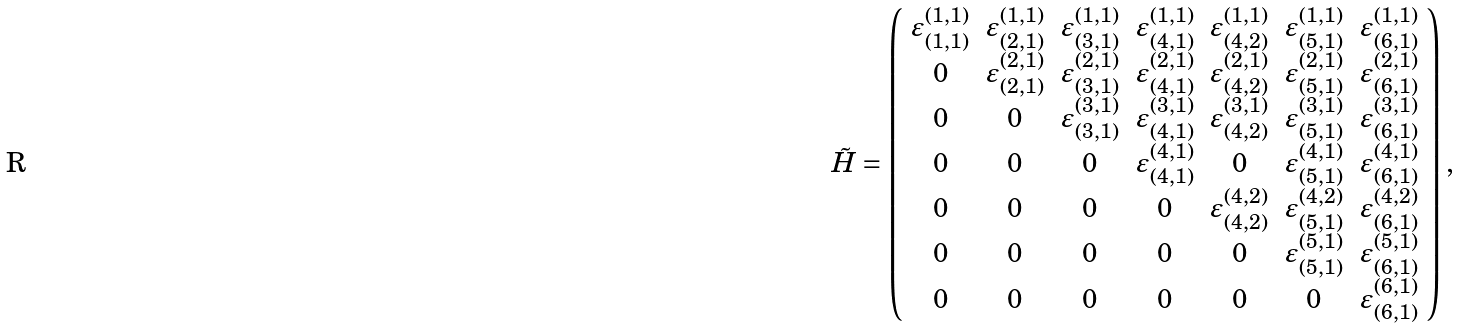Convert formula to latex. <formula><loc_0><loc_0><loc_500><loc_500>\tilde { H } = \left ( \begin{array} { c c c c c c c } \varepsilon ^ { ( 1 , 1 ) } _ { ( 1 , 1 ) } & \varepsilon ^ { ( 1 , 1 ) } _ { ( 2 , 1 ) } & \varepsilon ^ { ( 1 , 1 ) } _ { ( 3 , 1 ) } & \varepsilon ^ { ( 1 , 1 ) } _ { ( 4 , 1 ) } & \varepsilon ^ { ( 1 , 1 ) } _ { ( 4 , 2 ) } & \varepsilon ^ { ( 1 , 1 ) } _ { ( 5 , 1 ) } & \varepsilon ^ { ( 1 , 1 ) } _ { ( 6 , 1 ) } \\ 0 & \varepsilon ^ { ( 2 , 1 ) } _ { ( 2 , 1 ) } & \varepsilon ^ { ( 2 , 1 ) } _ { ( 3 , 1 ) } & \varepsilon ^ { ( 2 , 1 ) } _ { ( 4 , 1 ) } & \varepsilon ^ { ( 2 , 1 ) } _ { ( 4 , 2 ) } & \varepsilon ^ { ( 2 , 1 ) } _ { ( 5 , 1 ) } & \varepsilon ^ { ( 2 , 1 ) } _ { ( 6 , 1 ) } \\ 0 & 0 & \varepsilon ^ { ( 3 , 1 ) } _ { ( 3 , 1 ) } & \varepsilon ^ { ( 3 , 1 ) } _ { ( 4 , 1 ) } & \varepsilon ^ { ( 3 , 1 ) } _ { ( 4 , 2 ) } & \varepsilon ^ { ( 3 , 1 ) } _ { ( 5 , 1 ) } & \varepsilon ^ { ( 3 , 1 ) } _ { ( 6 , 1 ) } \\ 0 & 0 & 0 & \varepsilon ^ { ( 4 , 1 ) } _ { ( 4 , 1 ) } & 0 & \varepsilon ^ { ( 4 , 1 ) } _ { ( 5 , 1 ) } & \varepsilon ^ { ( 4 , 1 ) } _ { ( 6 , 1 ) } \\ 0 & 0 & 0 & 0 & \varepsilon ^ { ( 4 , 2 ) } _ { ( 4 , 2 ) } & \varepsilon ^ { ( 4 , 2 ) } _ { ( 5 , 1 ) } & \varepsilon ^ { ( 4 , 2 ) } _ { ( 6 , 1 ) } \\ 0 & 0 & 0 & 0 & 0 & \varepsilon ^ { ( 5 , 1 ) } _ { ( 5 , 1 ) } & \varepsilon ^ { ( 5 , 1 ) } _ { ( 6 , 1 ) } \\ 0 & 0 & 0 & 0 & 0 & 0 & \varepsilon ^ { ( 6 , 1 ) } _ { ( 6 , 1 ) } \end{array} \right ) ,</formula> 